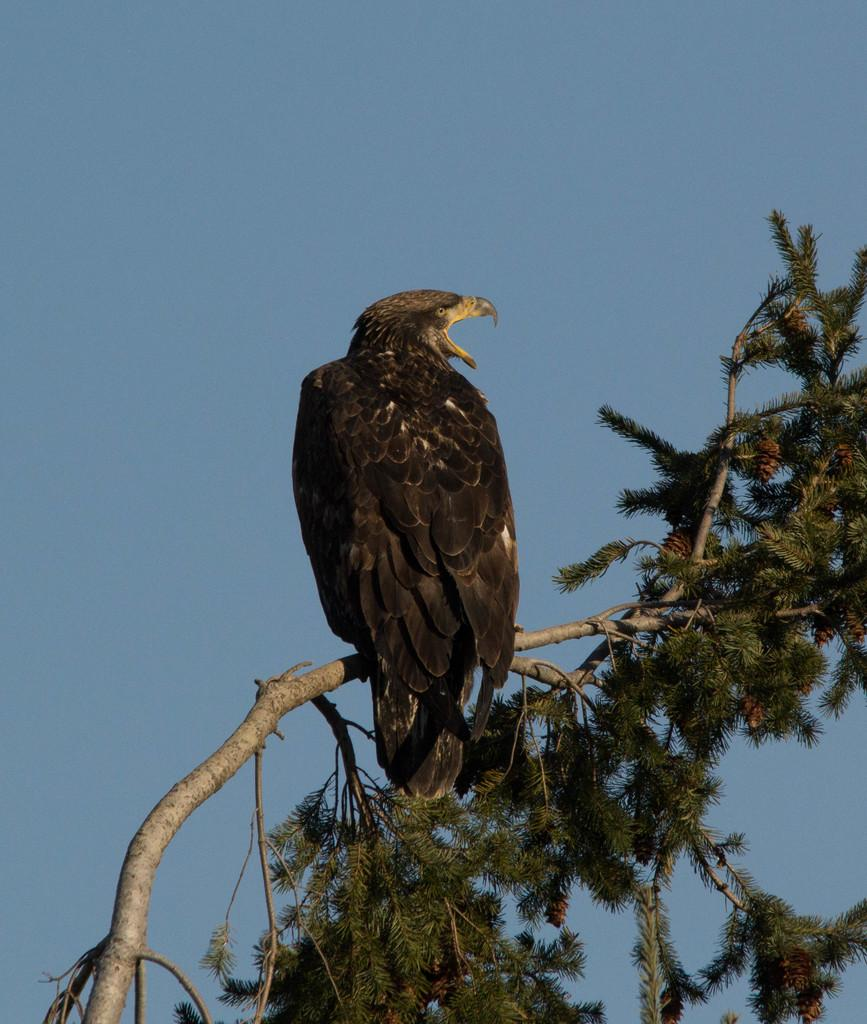What type of animal can be seen in the image? There is a bird in the image. Where is the bird located? The bird is on a tree. What can be seen in the background of the image? There is sky visible in the background of the image. What type of music is the bird playing in the image? There is no indication in the image that the bird is playing any music, as birds do not have the ability to play musical instruments. 